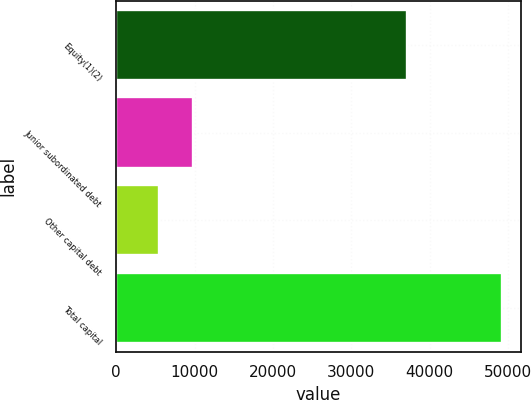Convert chart to OTSL. <chart><loc_0><loc_0><loc_500><loc_500><bar_chart><fcel>Equity(1)(2)<fcel>Junior subordinated debt<fcel>Other capital debt<fcel>Total capital<nl><fcel>37162<fcel>9780.4<fcel>5402<fcel>49186<nl></chart> 